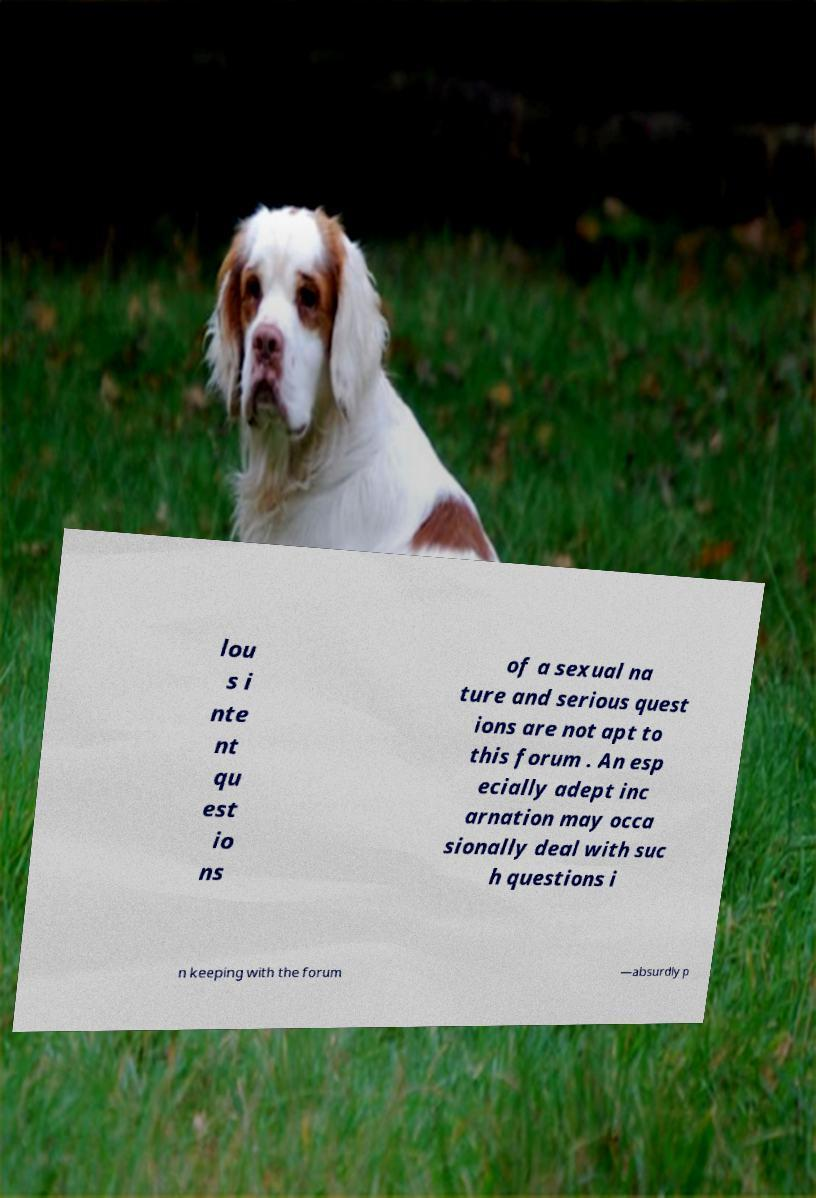For documentation purposes, I need the text within this image transcribed. Could you provide that? lou s i nte nt qu est io ns of a sexual na ture and serious quest ions are not apt to this forum . An esp ecially adept inc arnation may occa sionally deal with suc h questions i n keeping with the forum —absurdly p 